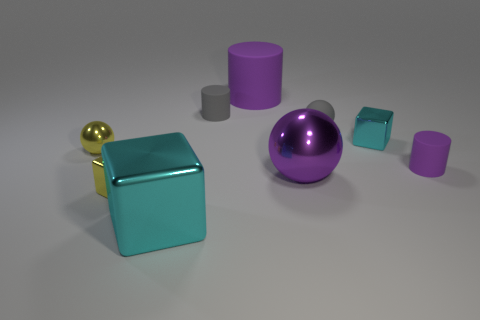Add 1 tiny balls. How many objects exist? 10 Subtract all cylinders. How many objects are left? 6 Add 1 big cyan cubes. How many big cyan cubes exist? 2 Subtract 0 cyan balls. How many objects are left? 9 Subtract all big matte things. Subtract all small rubber spheres. How many objects are left? 7 Add 2 purple metallic balls. How many purple metallic balls are left? 3 